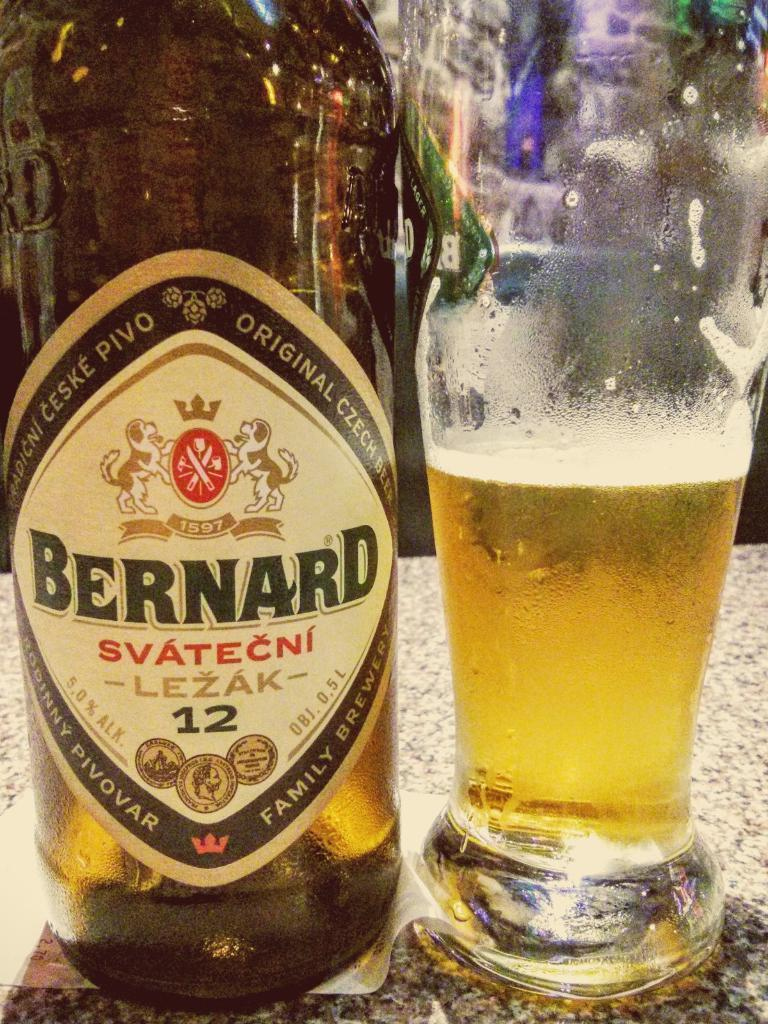<image>
Present a compact description of the photo's key features. A bottle of Bernard Svatecni beer next to a glass. 